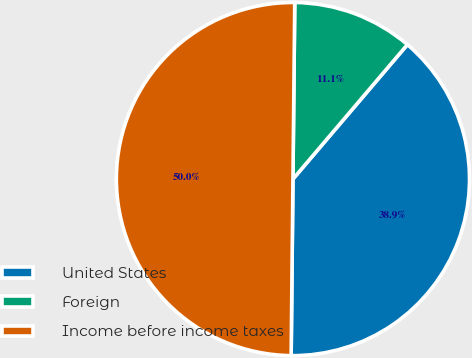<chart> <loc_0><loc_0><loc_500><loc_500><pie_chart><fcel>United States<fcel>Foreign<fcel>Income before income taxes<nl><fcel>38.94%<fcel>11.06%<fcel>50.0%<nl></chart> 